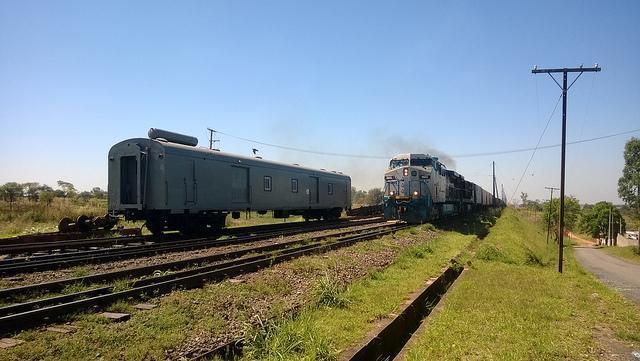How many trains are moving?
Give a very brief answer. 1. How many train tracks are there?
Give a very brief answer. 2. How many trains can be seen?
Give a very brief answer. 2. 